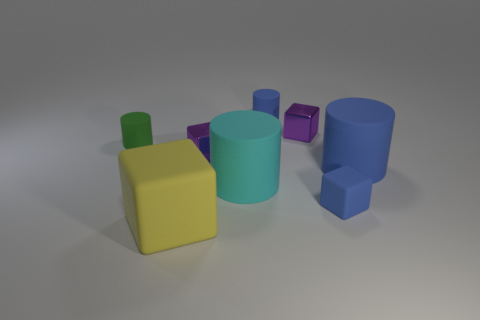There is a tiny blue matte object behind the rubber block that is to the right of the big matte cube; what is its shape? The tiny blue matte object located behind the rubber block, which is to the right of the large matte cube, is a cylinder in shape. 